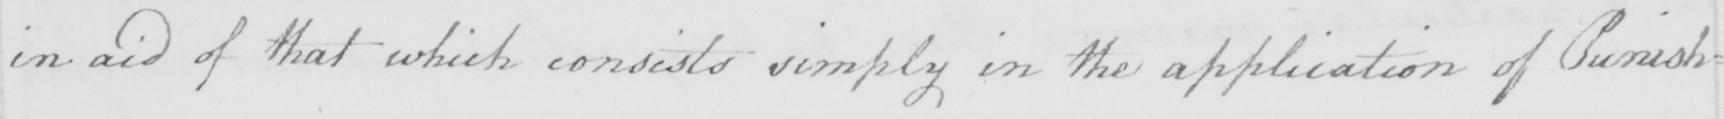What does this handwritten line say? in aid of that which consists simply in the application of Punish= 